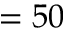Convert formula to latex. <formula><loc_0><loc_0><loc_500><loc_500>= 5 0</formula> 